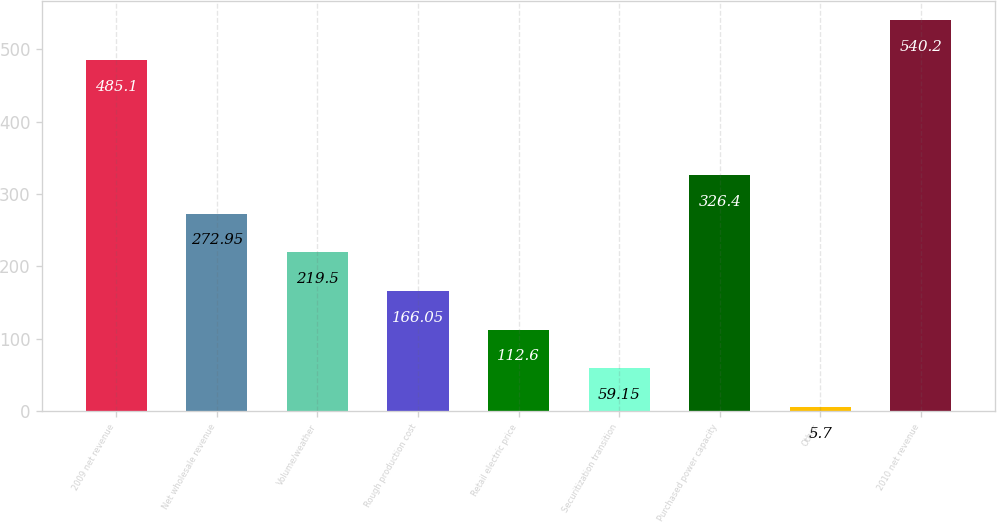<chart> <loc_0><loc_0><loc_500><loc_500><bar_chart><fcel>2009 net revenue<fcel>Net wholesale revenue<fcel>Volume/weather<fcel>Rough production cost<fcel>Retail electric price<fcel>Securitization transition<fcel>Purchased power capacity<fcel>Other<fcel>2010 net revenue<nl><fcel>485.1<fcel>272.95<fcel>219.5<fcel>166.05<fcel>112.6<fcel>59.15<fcel>326.4<fcel>5.7<fcel>540.2<nl></chart> 